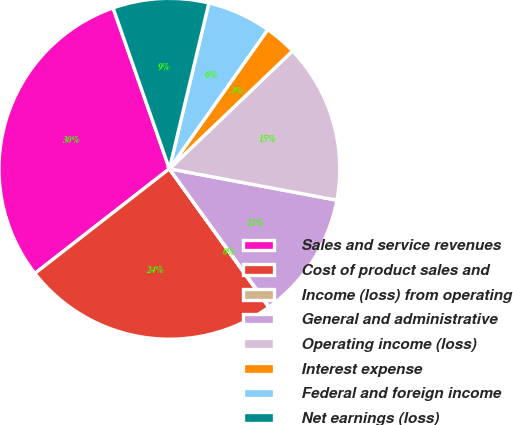Convert chart to OTSL. <chart><loc_0><loc_0><loc_500><loc_500><pie_chart><fcel>Sales and service revenues<fcel>Cost of product sales and<fcel>Income (loss) from operating<fcel>General and administrative<fcel>Operating income (loss)<fcel>Interest expense<fcel>Federal and foreign income<fcel>Net earnings (loss)<nl><fcel>30.16%<fcel>24.39%<fcel>0.05%<fcel>12.09%<fcel>15.1%<fcel>3.06%<fcel>6.07%<fcel>9.08%<nl></chart> 